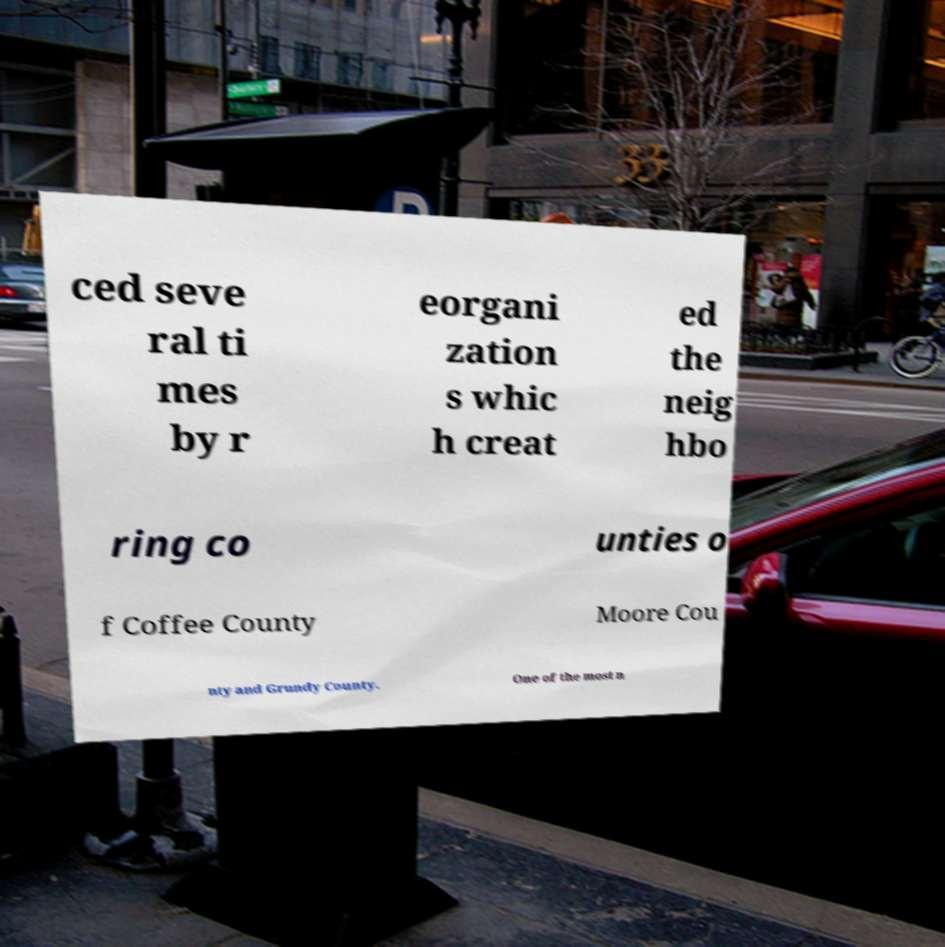Can you read and provide the text displayed in the image?This photo seems to have some interesting text. Can you extract and type it out for me? ced seve ral ti mes by r eorgani zation s whic h creat ed the neig hbo ring co unties o f Coffee County Moore Cou nty and Grundy County. One of the most n 